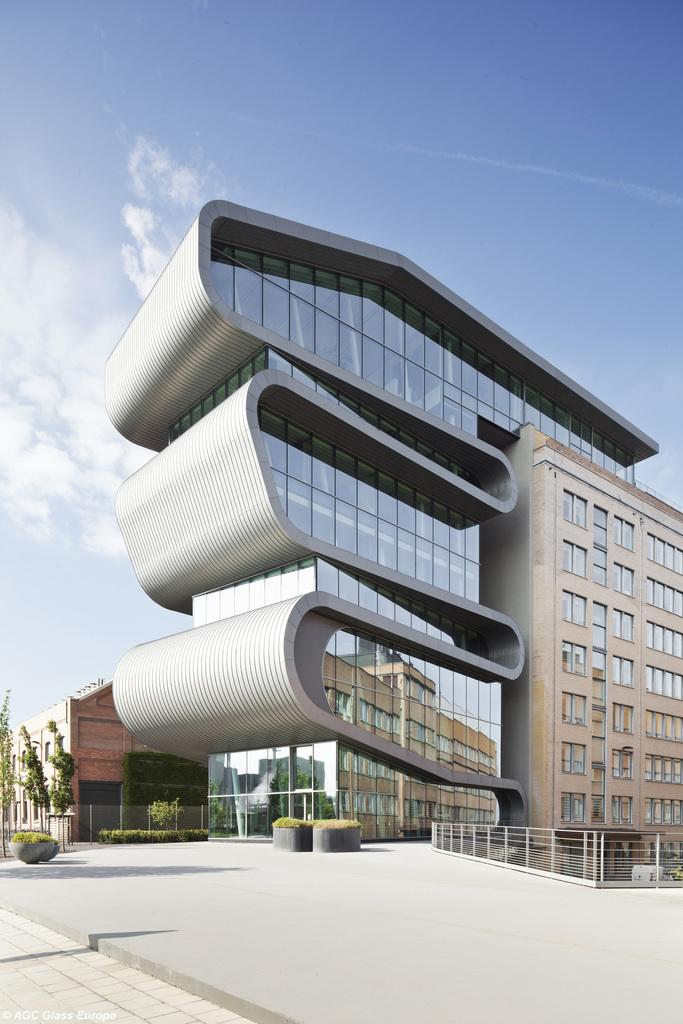What is the main structure in the picture? There is a big building in the picture. What type of organization might the building belong to? The building appears to be an organization. What can be seen in front of the building? There are trees and plants in front of the building. What book is the mother reading to her child in front of the building? There is no book or mother with a child present in the image. 